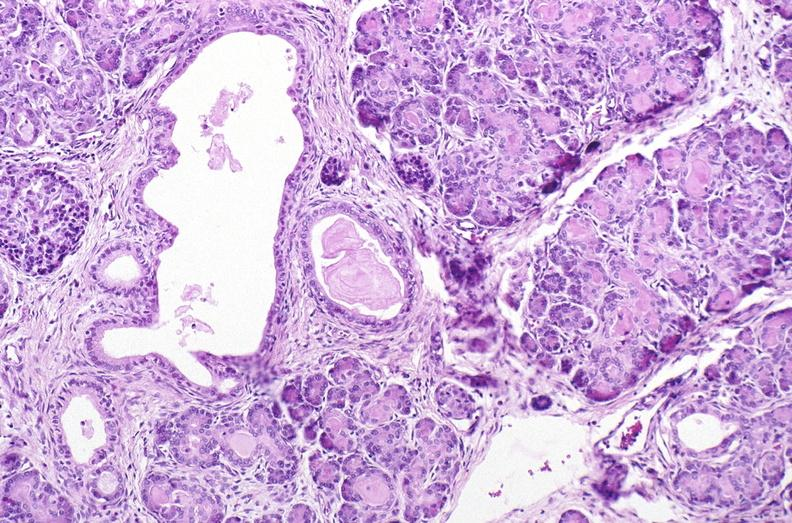s bread-loaf slices into prostate gland present?
Answer the question using a single word or phrase. No 